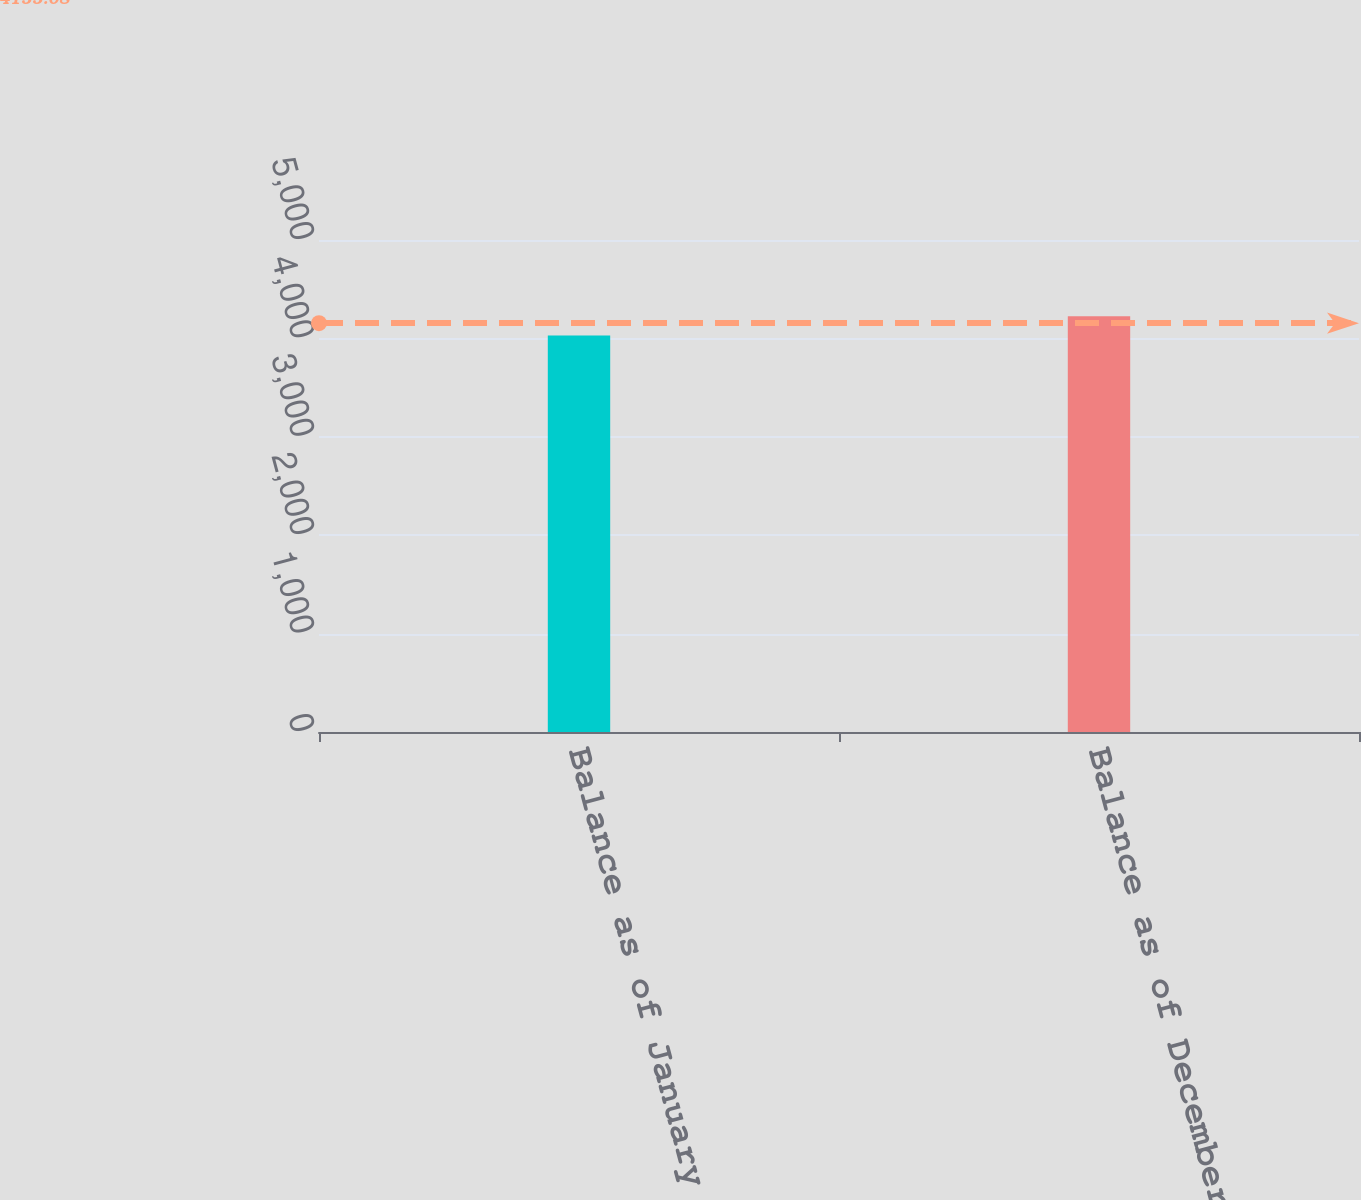Convert chart to OTSL. <chart><loc_0><loc_0><loc_500><loc_500><bar_chart><fcel>Balance as of January 1<fcel>Balance as of December 31<nl><fcel>4029<fcel>4224<nl></chart> 